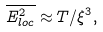<formula> <loc_0><loc_0><loc_500><loc_500>\overline { { E } _ { l o c } ^ { 2 } } \approx T / \xi ^ { 3 } ,</formula> 